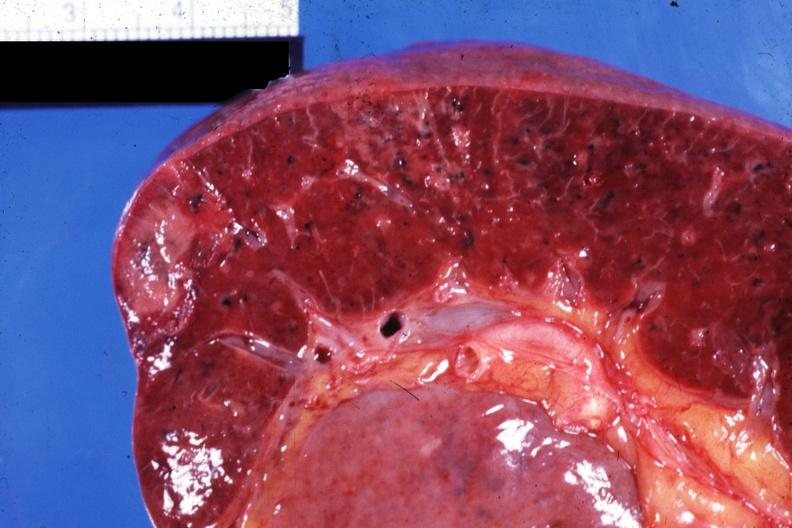does this image show close-up view of infarcts due to nonbacterial endocarditis 88yom with body burns?
Answer the question using a single word or phrase. Yes 